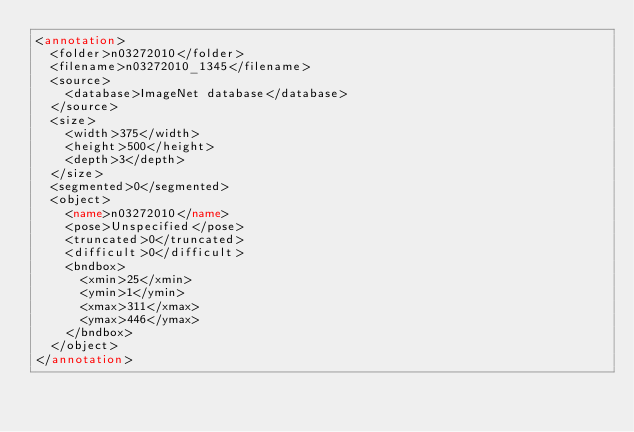Convert code to text. <code><loc_0><loc_0><loc_500><loc_500><_XML_><annotation>
	<folder>n03272010</folder>
	<filename>n03272010_1345</filename>
	<source>
		<database>ImageNet database</database>
	</source>
	<size>
		<width>375</width>
		<height>500</height>
		<depth>3</depth>
	</size>
	<segmented>0</segmented>
	<object>
		<name>n03272010</name>
		<pose>Unspecified</pose>
		<truncated>0</truncated>
		<difficult>0</difficult>
		<bndbox>
			<xmin>25</xmin>
			<ymin>1</ymin>
			<xmax>311</xmax>
			<ymax>446</ymax>
		</bndbox>
	</object>
</annotation></code> 